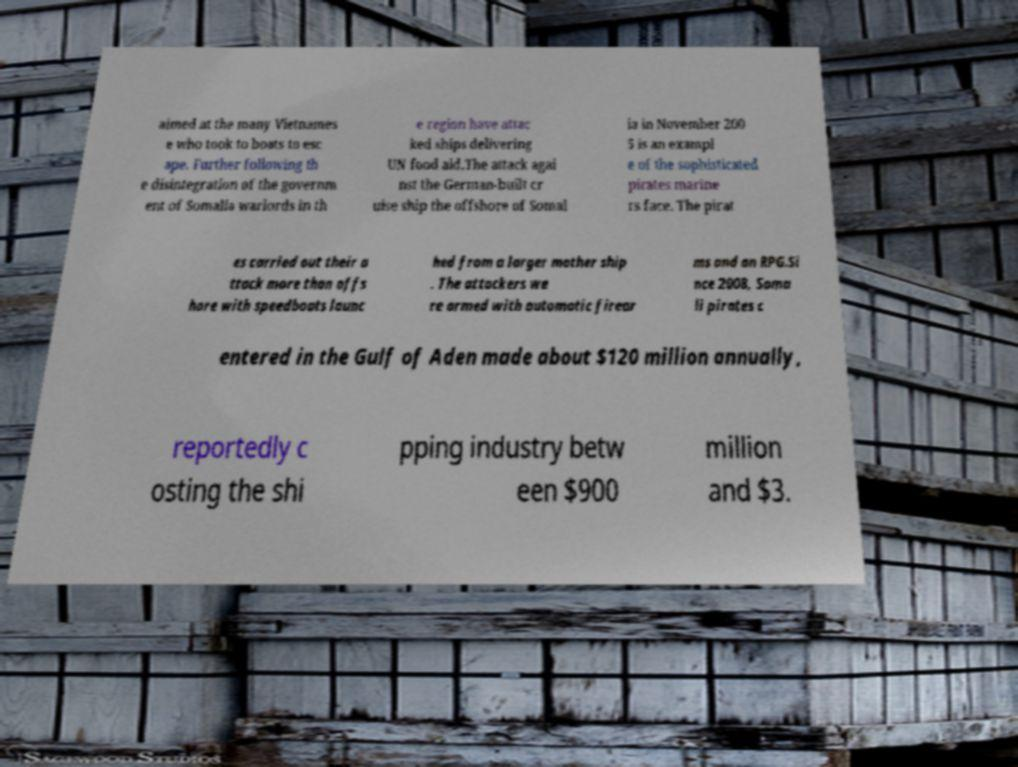Please identify and transcribe the text found in this image. aimed at the many Vietnames e who took to boats to esc ape. Further following th e disintegration of the governm ent of Somalia warlords in th e region have attac ked ships delivering UN food aid.The attack agai nst the German-built cr uise ship the offshore of Somal ia in November 200 5 is an exampl e of the sophisticated pirates marine rs face. The pirat es carried out their a ttack more than offs hore with speedboats launc hed from a larger mother ship . The attackers we re armed with automatic firear ms and an RPG.Si nce 2008, Soma li pirates c entered in the Gulf of Aden made about $120 million annually, reportedly c osting the shi pping industry betw een $900 million and $3. 